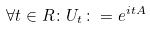Convert formula to latex. <formula><loc_0><loc_0><loc_500><loc_500>\forall t \in R \colon U _ { t } \colon = e ^ { i t A }</formula> 